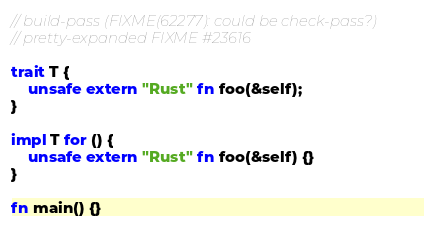Convert code to text. <code><loc_0><loc_0><loc_500><loc_500><_Rust_>// build-pass (FIXME(62277): could be check-pass?)
// pretty-expanded FIXME #23616

trait T {
    unsafe extern "Rust" fn foo(&self);
}

impl T for () {
    unsafe extern "Rust" fn foo(&self) {}
}

fn main() {}
</code> 